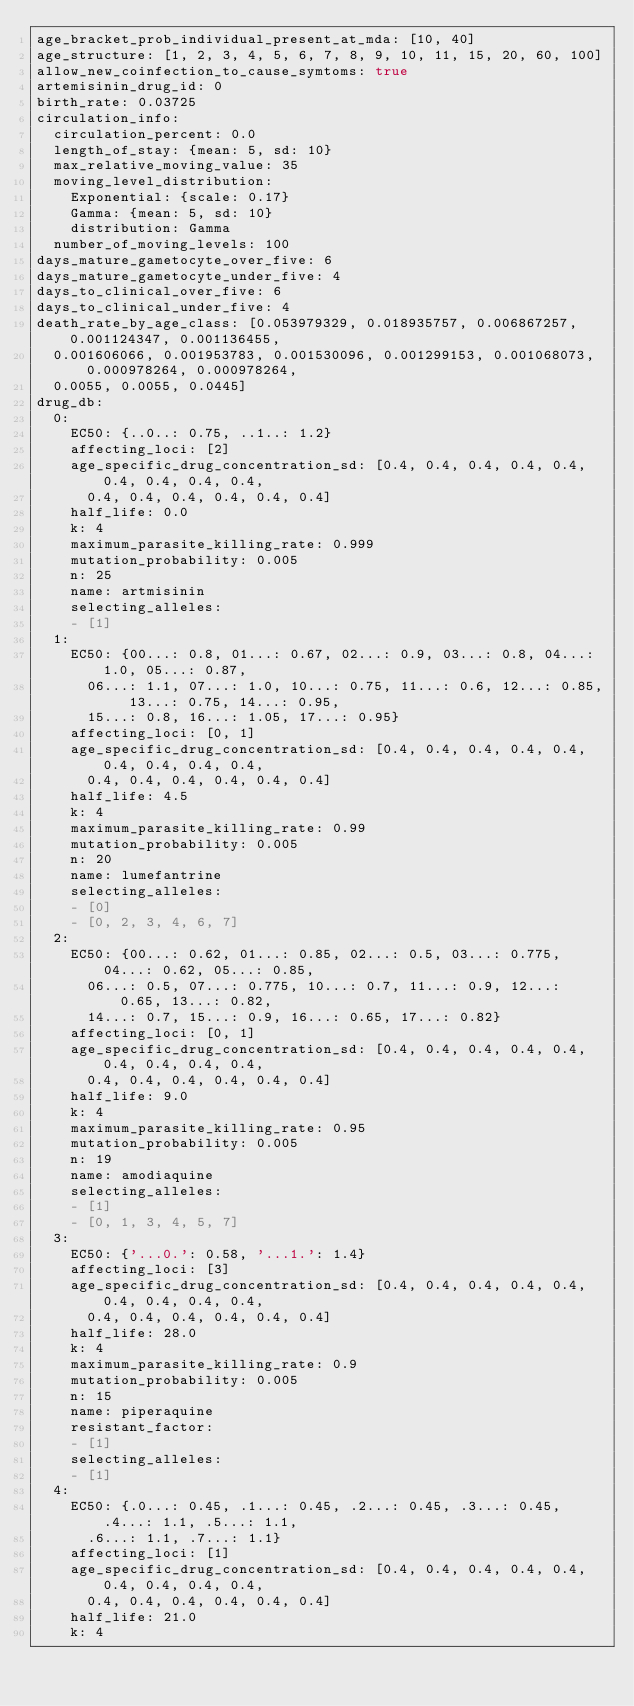<code> <loc_0><loc_0><loc_500><loc_500><_YAML_>age_bracket_prob_individual_present_at_mda: [10, 40]
age_structure: [1, 2, 3, 4, 5, 6, 7, 8, 9, 10, 11, 15, 20, 60, 100]
allow_new_coinfection_to_cause_symtoms: true
artemisinin_drug_id: 0
birth_rate: 0.03725
circulation_info:
  circulation_percent: 0.0
  length_of_stay: {mean: 5, sd: 10}
  max_relative_moving_value: 35
  moving_level_distribution:
    Exponential: {scale: 0.17}
    Gamma: {mean: 5, sd: 10}
    distribution: Gamma
  number_of_moving_levels: 100
days_mature_gametocyte_over_five: 6
days_mature_gametocyte_under_five: 4
days_to_clinical_over_five: 6
days_to_clinical_under_five: 4
death_rate_by_age_class: [0.053979329, 0.018935757, 0.006867257, 0.001124347, 0.001136455,
  0.001606066, 0.001953783, 0.001530096, 0.001299153, 0.001068073, 0.000978264, 0.000978264,
  0.0055, 0.0055, 0.0445]
drug_db:
  0:
    EC50: {..0..: 0.75, ..1..: 1.2}
    affecting_loci: [2]
    age_specific_drug_concentration_sd: [0.4, 0.4, 0.4, 0.4, 0.4, 0.4, 0.4, 0.4, 0.4,
      0.4, 0.4, 0.4, 0.4, 0.4, 0.4]
    half_life: 0.0
    k: 4
    maximum_parasite_killing_rate: 0.999
    mutation_probability: 0.005
    n: 25
    name: artmisinin
    selecting_alleles:
    - [1]
  1:
    EC50: {00...: 0.8, 01...: 0.67, 02...: 0.9, 03...: 0.8, 04...: 1.0, 05...: 0.87,
      06...: 1.1, 07...: 1.0, 10...: 0.75, 11...: 0.6, 12...: 0.85, 13...: 0.75, 14...: 0.95,
      15...: 0.8, 16...: 1.05, 17...: 0.95}
    affecting_loci: [0, 1]
    age_specific_drug_concentration_sd: [0.4, 0.4, 0.4, 0.4, 0.4, 0.4, 0.4, 0.4, 0.4,
      0.4, 0.4, 0.4, 0.4, 0.4, 0.4]
    half_life: 4.5
    k: 4
    maximum_parasite_killing_rate: 0.99
    mutation_probability: 0.005
    n: 20
    name: lumefantrine
    selecting_alleles:
    - [0]
    - [0, 2, 3, 4, 6, 7]
  2:
    EC50: {00...: 0.62, 01...: 0.85, 02...: 0.5, 03...: 0.775, 04...: 0.62, 05...: 0.85,
      06...: 0.5, 07...: 0.775, 10...: 0.7, 11...: 0.9, 12...: 0.65, 13...: 0.82,
      14...: 0.7, 15...: 0.9, 16...: 0.65, 17...: 0.82}
    affecting_loci: [0, 1]
    age_specific_drug_concentration_sd: [0.4, 0.4, 0.4, 0.4, 0.4, 0.4, 0.4, 0.4, 0.4,
      0.4, 0.4, 0.4, 0.4, 0.4, 0.4]
    half_life: 9.0
    k: 4
    maximum_parasite_killing_rate: 0.95
    mutation_probability: 0.005
    n: 19
    name: amodiaquine
    selecting_alleles:
    - [1]
    - [0, 1, 3, 4, 5, 7]
  3:
    EC50: {'...0.': 0.58, '...1.': 1.4}
    affecting_loci: [3]
    age_specific_drug_concentration_sd: [0.4, 0.4, 0.4, 0.4, 0.4, 0.4, 0.4, 0.4, 0.4,
      0.4, 0.4, 0.4, 0.4, 0.4, 0.4]
    half_life: 28.0
    k: 4
    maximum_parasite_killing_rate: 0.9
    mutation_probability: 0.005
    n: 15
    name: piperaquine
    resistant_factor:
    - [1]
    selecting_alleles:
    - [1]
  4:
    EC50: {.0...: 0.45, .1...: 0.45, .2...: 0.45, .3...: 0.45, .4...: 1.1, .5...: 1.1,
      .6...: 1.1, .7...: 1.1}
    affecting_loci: [1]
    age_specific_drug_concentration_sd: [0.4, 0.4, 0.4, 0.4, 0.4, 0.4, 0.4, 0.4, 0.4,
      0.4, 0.4, 0.4, 0.4, 0.4, 0.4]
    half_life: 21.0
    k: 4</code> 